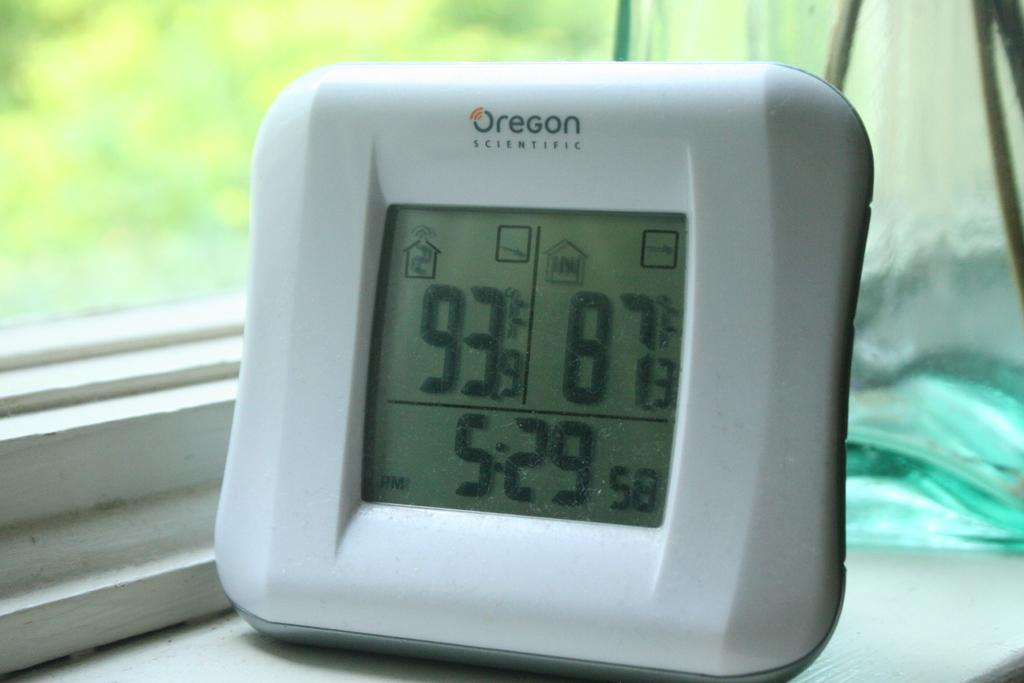What is the main object in the image? There is a digital meter in the image. What information does the digital meter display? The digital meter displays time. What can be seen on the left side of the image? There is a glass window on the left side of the image. What type of border is visible around the digital meter in the image? There is no border visible around the digital meter in the image. Does the existence of the digital meter in the image prove the existence of time? The digital meter displaying time in the image does not prove the existence of time, as time exists independently of the digital meter. 